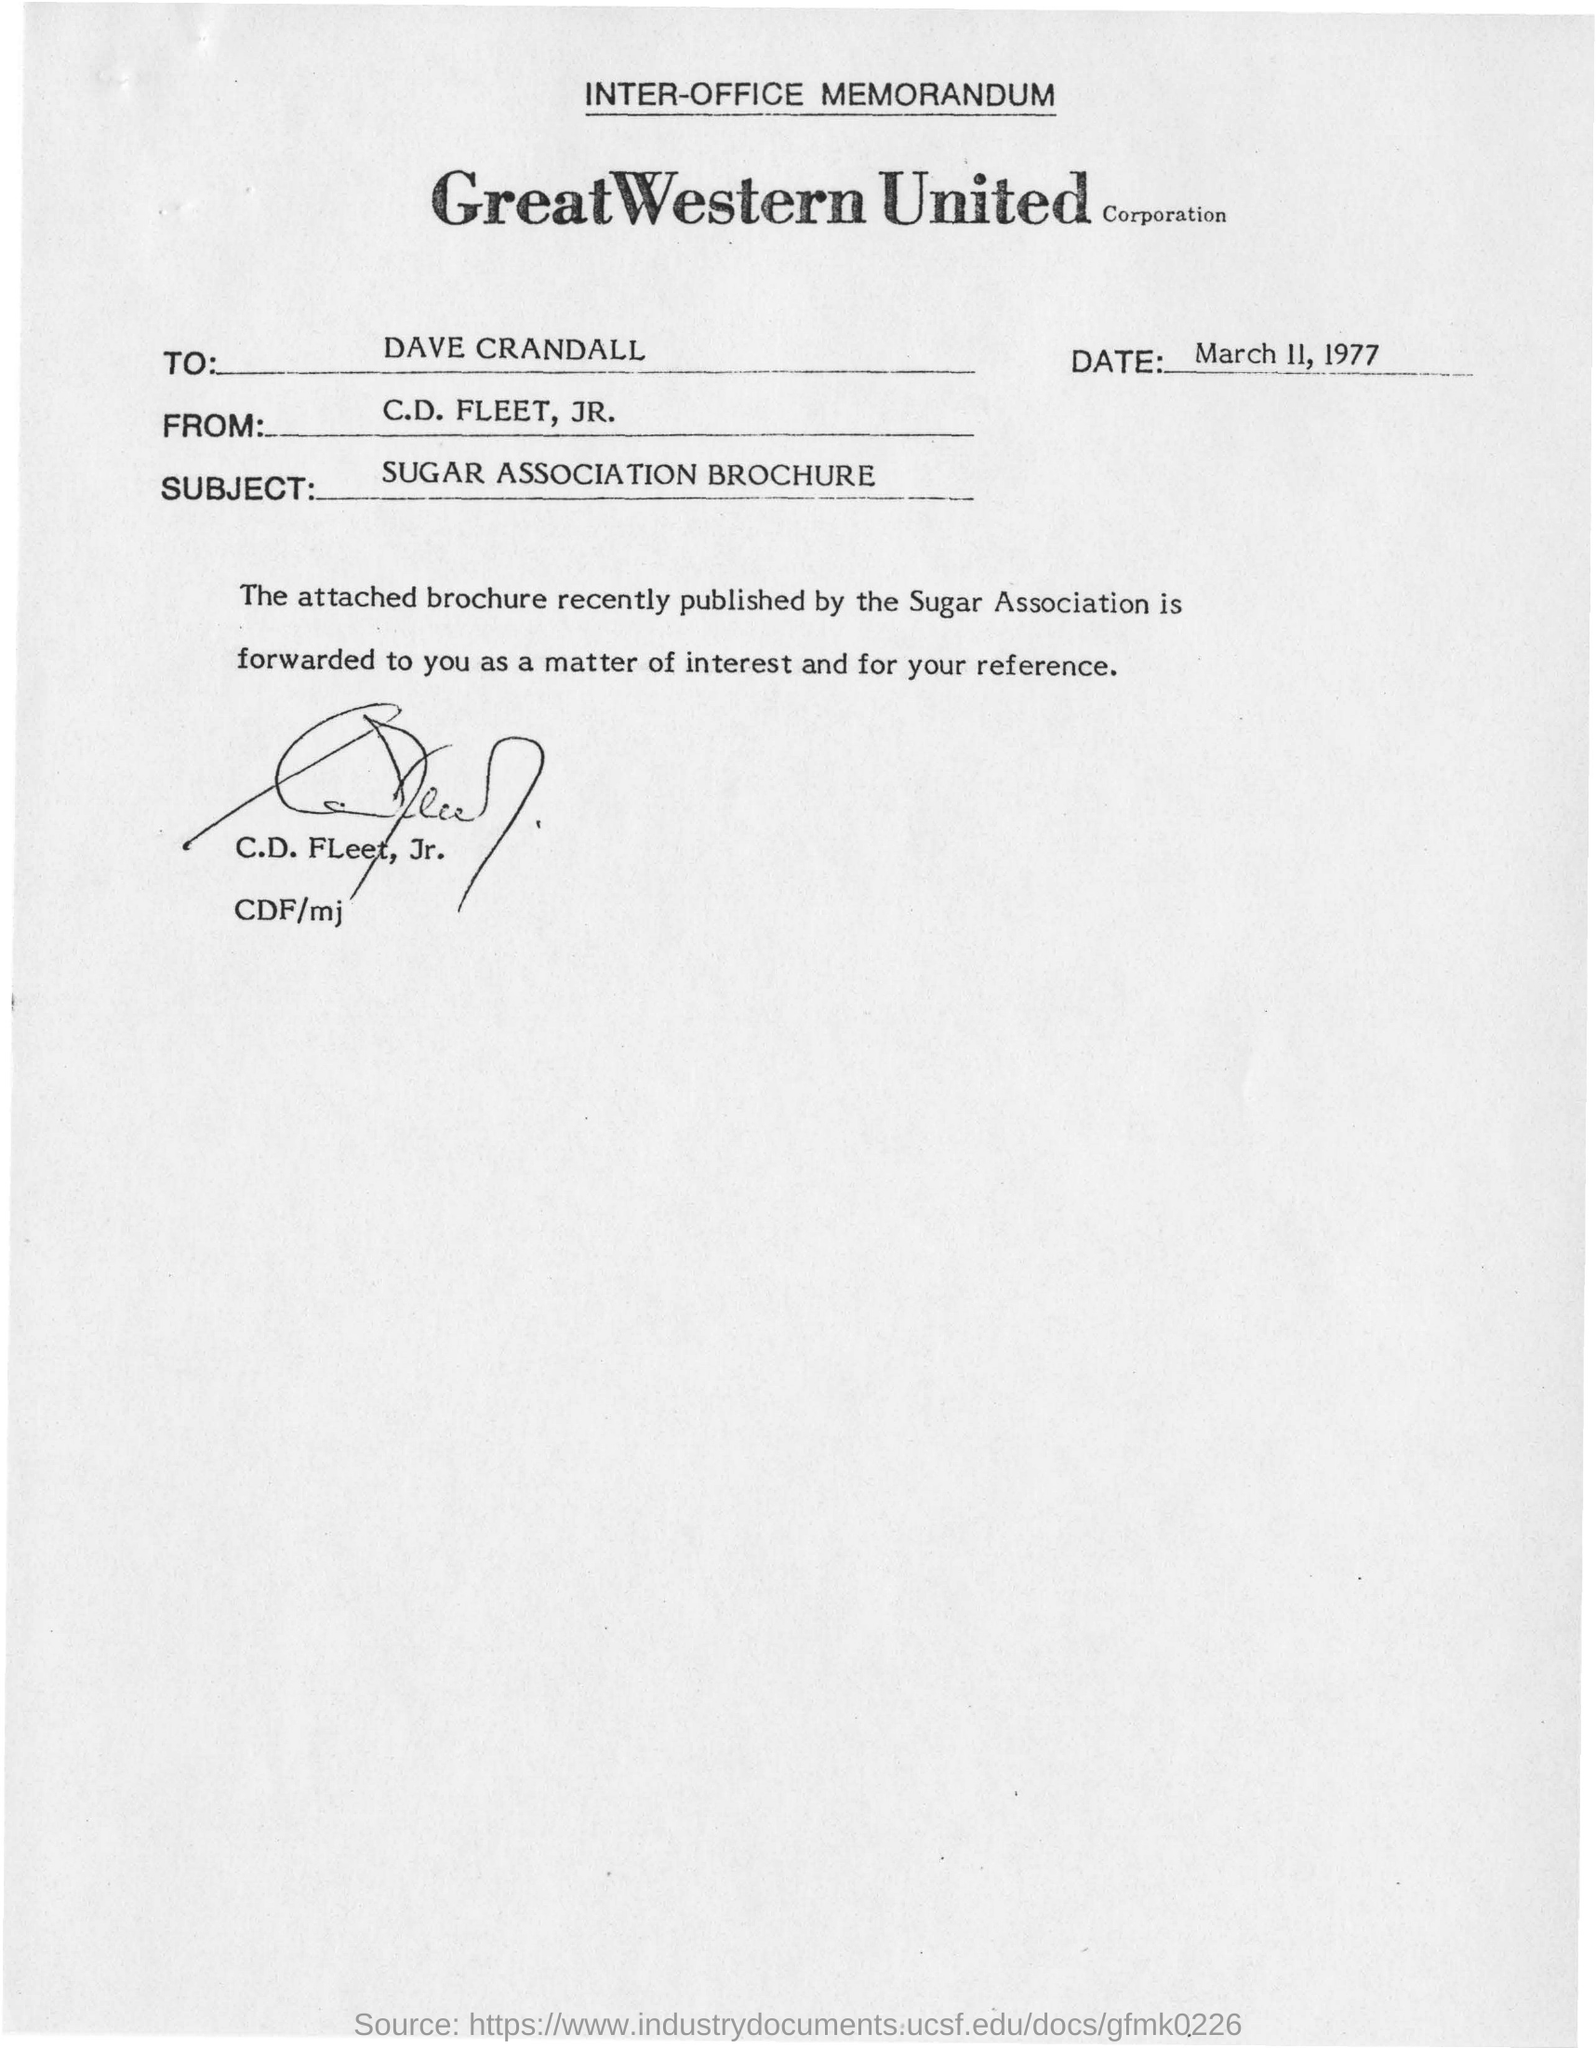Outline some significant characteristics in this image. The recipient of the memorandum is C.D. Fleet, JR. The memorandum is addressed to Dave Crandall. 